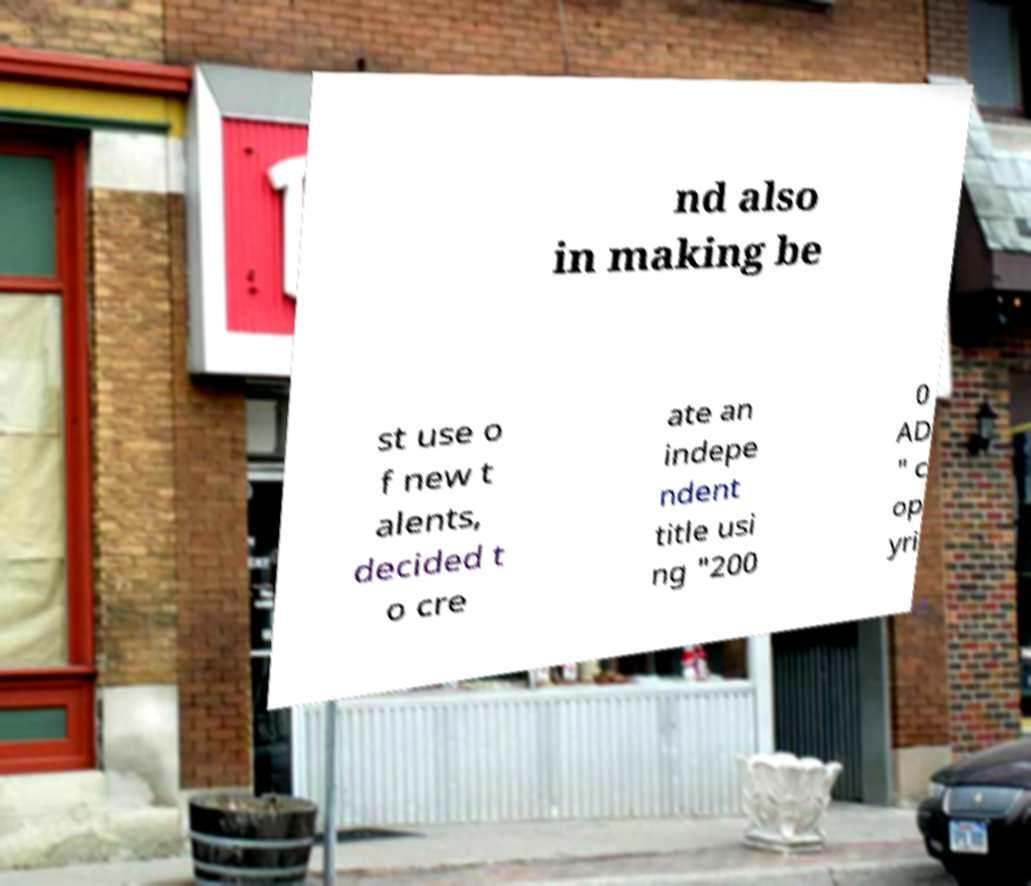Could you extract and type out the text from this image? nd also in making be st use o f new t alents, decided t o cre ate an indepe ndent title usi ng "200 0 AD " c op yri 